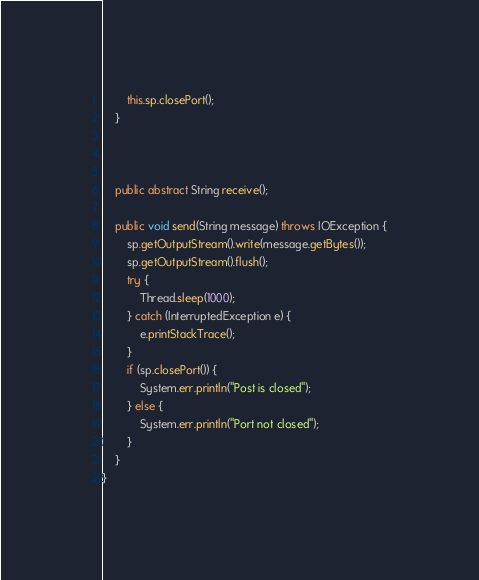<code> <loc_0><loc_0><loc_500><loc_500><_Java_>        this.sp.closePort();
    }



    public abstract String receive();

    public void send(String message) throws IOException {
        sp.getOutputStream().write(message.getBytes());
        sp.getOutputStream().flush();
        try {
            Thread.sleep(1000);
        } catch (InterruptedException e) {
            e.printStackTrace();
        }
        if (sp.closePort()) {
            System.err.println("Post is closed");
        } else {
            System.err.println("Port not closed");
        }
    }
}
</code> 